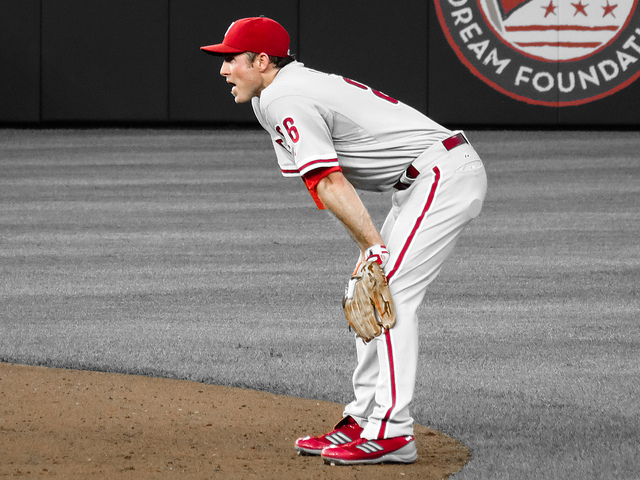Identify the text contained in this image. 6 6 REAM FOUNDAT 